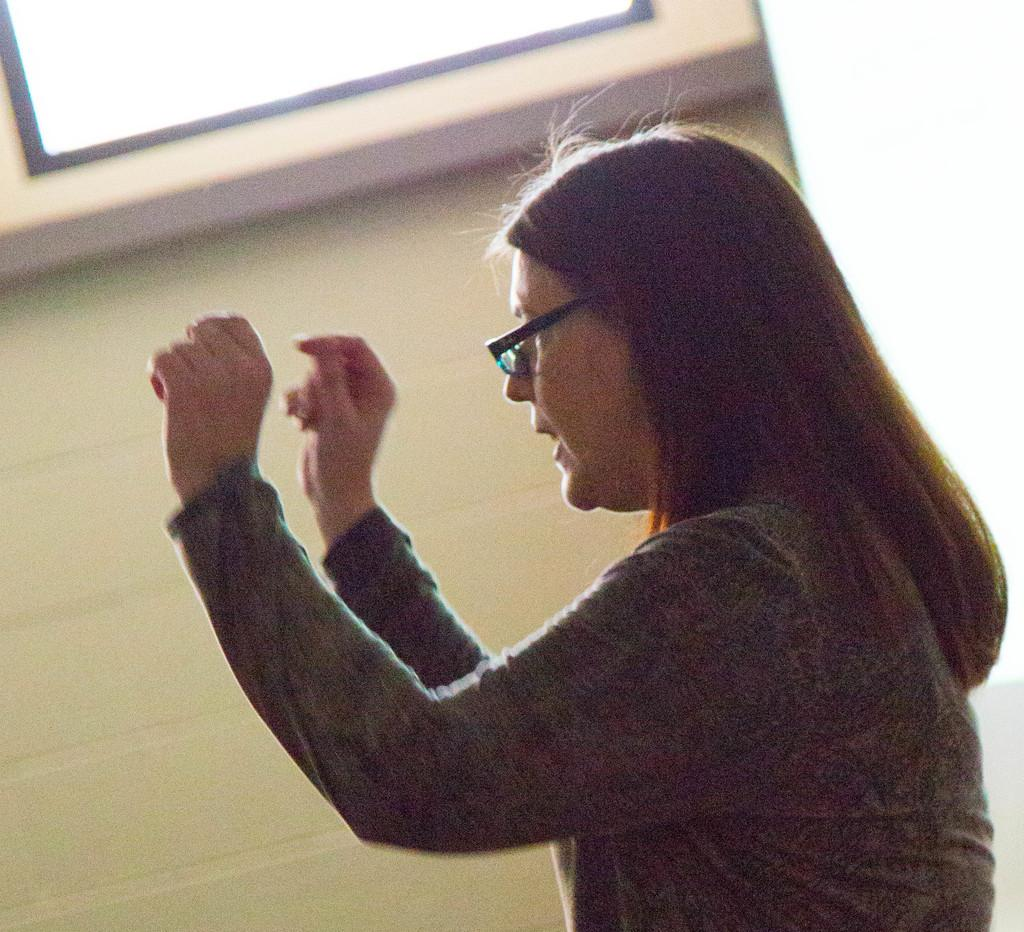Who is present in the image? There is a woman in the image. What is the woman wearing on her face? The woman is wearing spectacles. What type of clothing is the woman wearing? The woman is wearing a dress. What can be seen on the wall in the background of the image? There is a display screen on the wall in the background of the image. What type of pest can be seen crawling on the woman's dress in the image? There are no pests visible on the woman's dress in the image. What sound can be heard in the image due to the thunder? There is no thunder present in the image, so no such sound can be heard. 